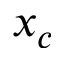<formula> <loc_0><loc_0><loc_500><loc_500>x _ { c }</formula> 